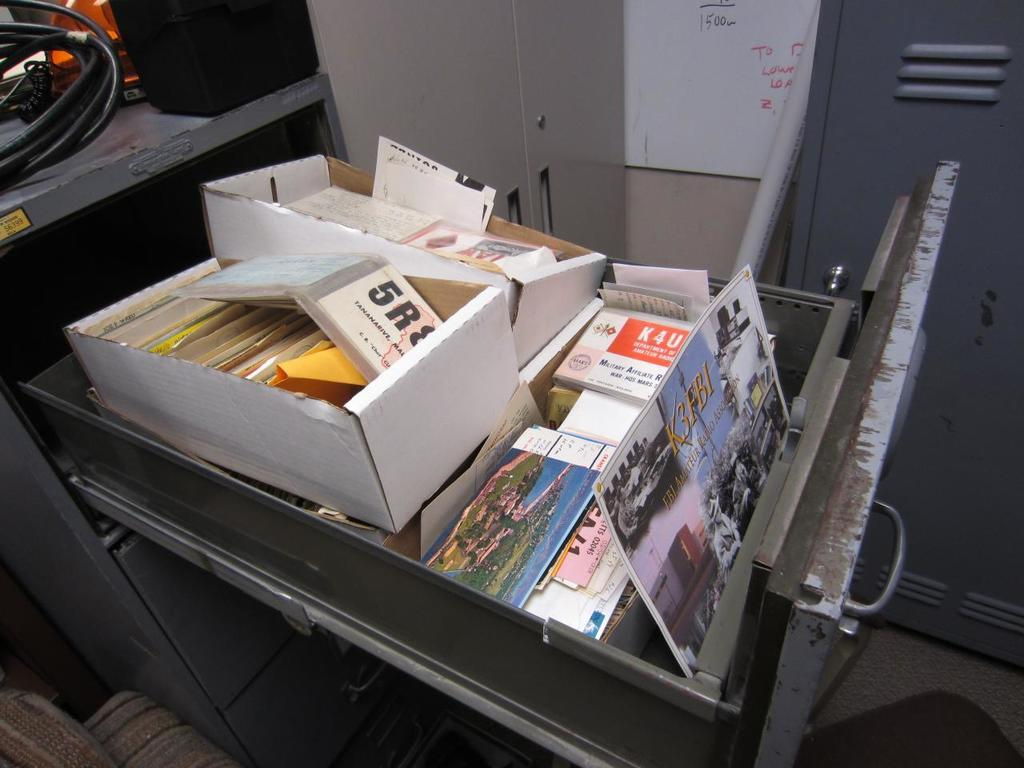<image>
Give a short and clear explanation of the subsequent image. A CD case labeled K4U sits in a drawer stuffed with other items. 